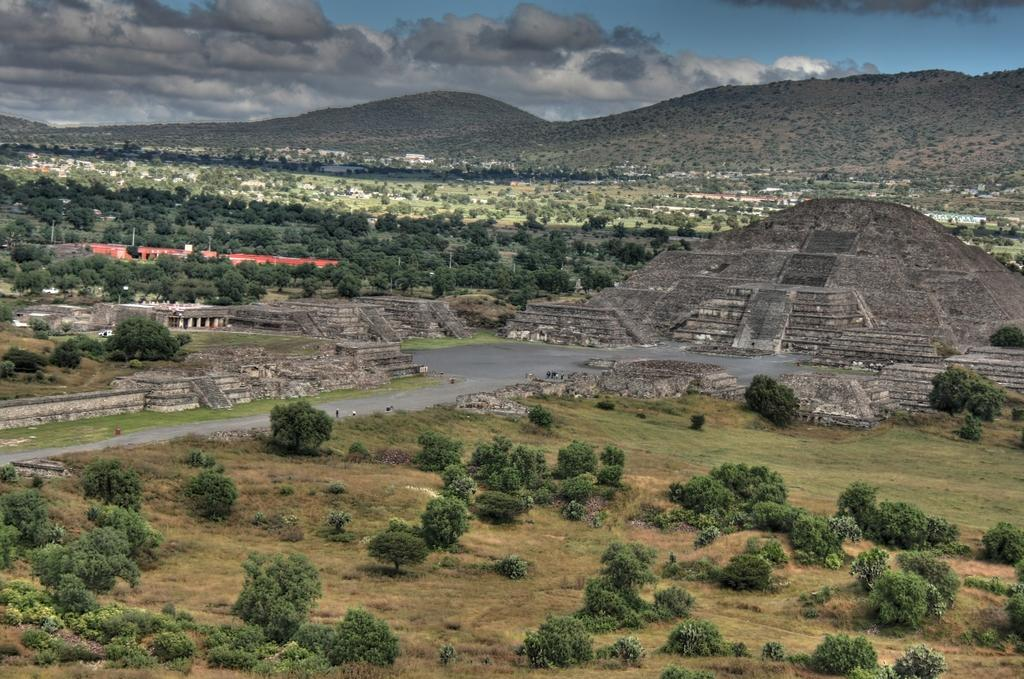What type of natural elements can be seen in the image? There are trees and plants in the image. What type of man-made structures are present in the image? There are buildings and a pyramid in the image. What is the terrain like in the image? There is a hill in the image. Are there any living beings in the image? Yes, there are people standing in the image. How would you describe the sky in the image? The sky is blue and cloudy. How many geese are flying over the pyramid in the image? There are no geese present in the image. What type of tool is being used to rake the leaves on the hill in the image? There is no rake or any indication of leaves being raked in the image. 